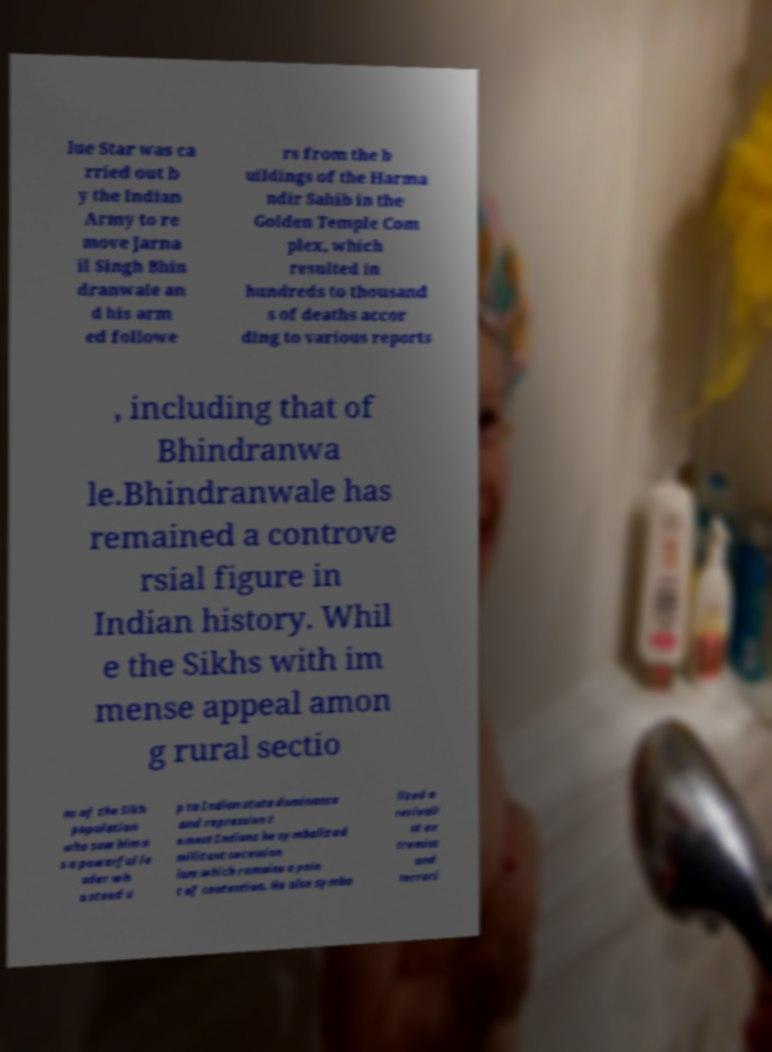Can you read and provide the text displayed in the image?This photo seems to have some interesting text. Can you extract and type it out for me? lue Star was ca rried out b y the Indian Army to re move Jarna il Singh Bhin dranwale an d his arm ed followe rs from the b uildings of the Harma ndir Sahib in the Golden Temple Com plex, which resulted in hundreds to thousand s of deaths accor ding to various reports , including that of Bhindranwa le.Bhindranwale has remained a controve rsial figure in Indian history. Whil e the Sikhs with im mense appeal amon g rural sectio ns of the Sikh population who saw him a s a powerful le ader wh o stood u p to Indian state dominance and repression t o most Indians he symbolized militant secession ism which remains a poin t of contention. He also symbo lized a revivali st ex tremist and terrori 